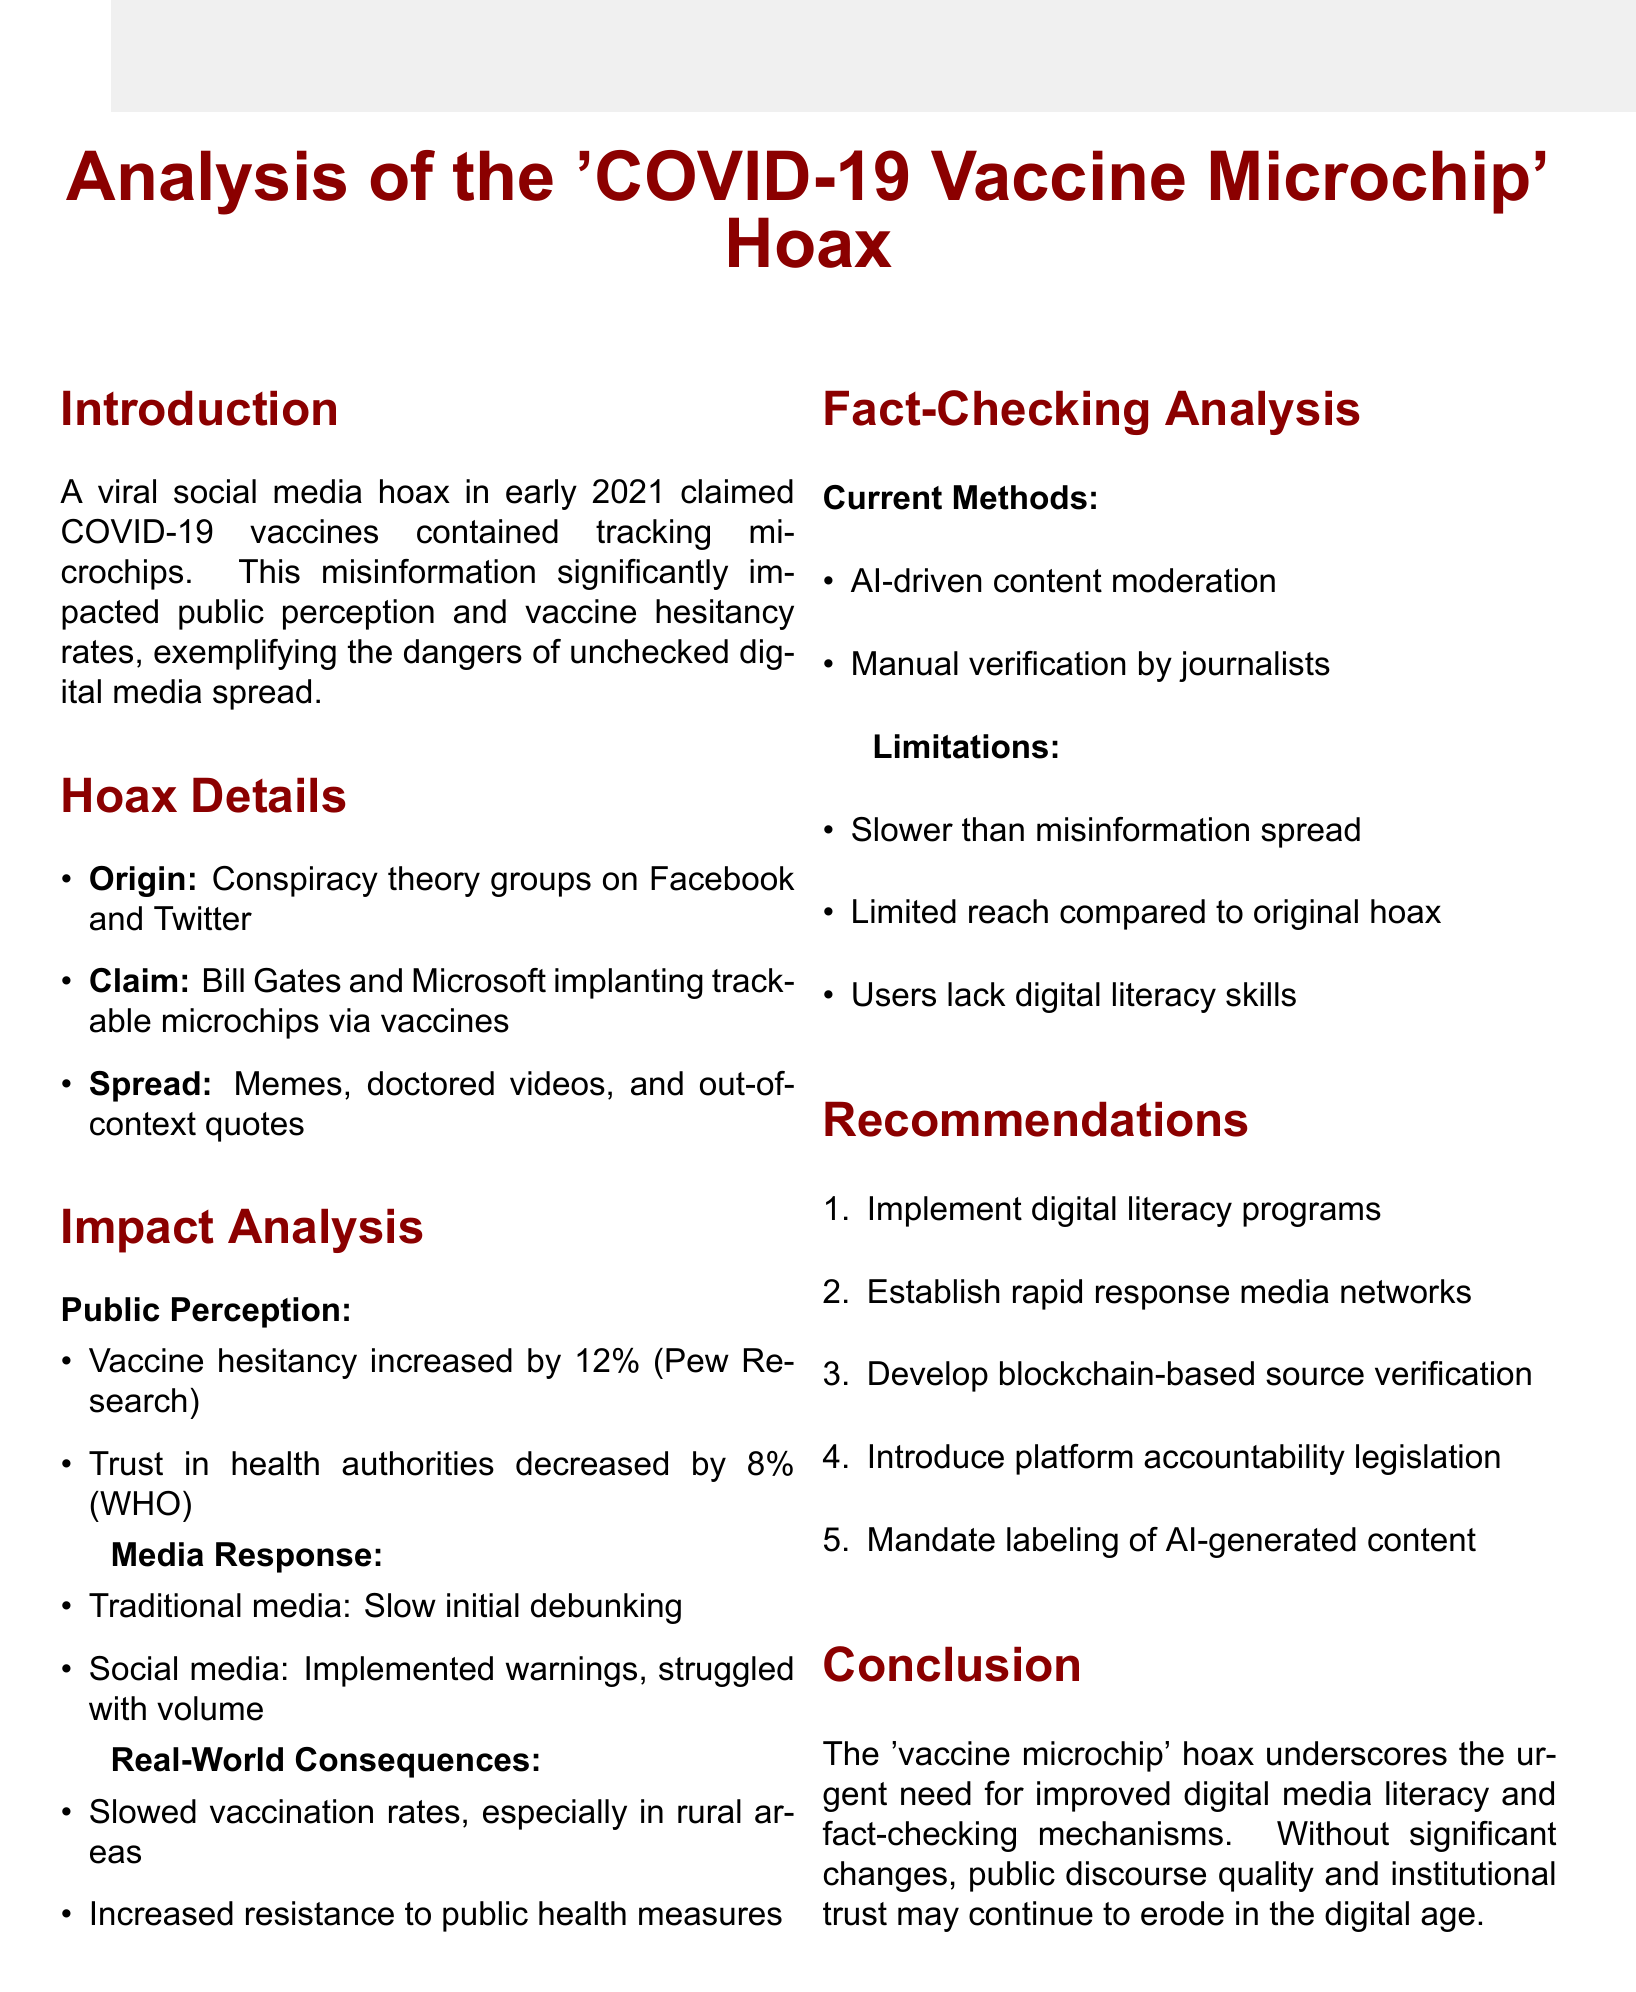What was the main claim of the hoax? The main claim was that vaccines contained microchips for tracking individuals.
Answer: Vaccines contained microchips for tracking individuals By what percentage did vaccine hesitancy increase? Vaccine hesitancy increased by 12% according to a Pew Research Center study.
Answer: 12% What year did the 'COVID-19 Vaccine Microchip' hoax go viral? The hoax claimed vaccines contained microchips in early 2021.
Answer: Early 2021 What is one limitation of current fact-checking methods mentioned? One limitation is that fact-checks are often slower than the spread of misinformation.
Answer: Slower than misinformation spread What is one recommendation made in the memo for improving fact-checking? One recommendation is to implement digital literacy programs in schools and adult education centers.
Answer: Implement digital literacy programs What was the origin of the hoax? The hoax originated from conspiracy theory groups on Facebook and Twitter.
Answer: Conspiracy theory groups on Facebook and Twitter How did traditional media initially respond to the hoax? Traditional media initially responded with slow debunking before providing fact-checks.
Answer: Slow initial debunking What percentage did trust in health authorities decrease? Trust in health authorities decreased by 8% as reported by the World Health Organization.
Answer: 8% 